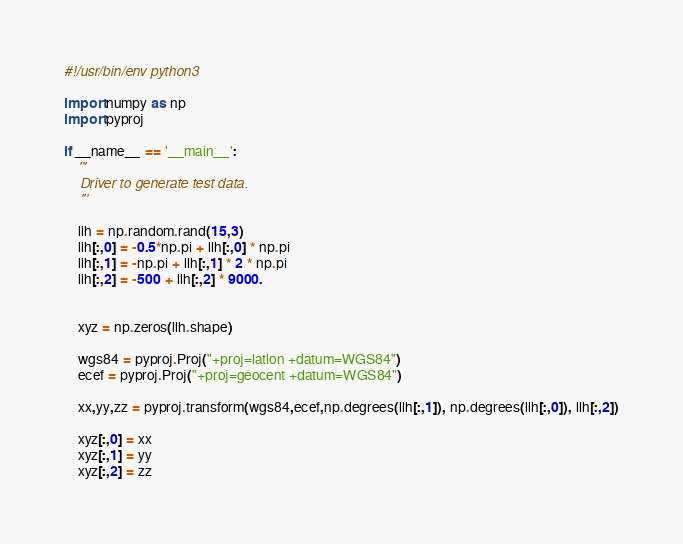<code> <loc_0><loc_0><loc_500><loc_500><_Python_>#!/usr/bin/env python3

import numpy as np
import pyproj

if __name__ == '__main__':
    '''
    Driver to generate test data.
    '''

    llh = np.random.rand(15,3)
    llh[:,0] = -0.5*np.pi + llh[:,0] * np.pi
    llh[:,1] = -np.pi + llh[:,1] * 2 * np.pi
    llh[:,2] = -500 + llh[:,2] * 9000.


    xyz = np.zeros(llh.shape)

    wgs84 = pyproj.Proj("+proj=latlon +datum=WGS84")
    ecef = pyproj.Proj("+proj=geocent +datum=WGS84")

    xx,yy,zz = pyproj.transform(wgs84,ecef,np.degrees(llh[:,1]), np.degrees(llh[:,0]), llh[:,2])

    xyz[:,0] = xx
    xyz[:,1] = yy
    xyz[:,2] = zz
</code> 